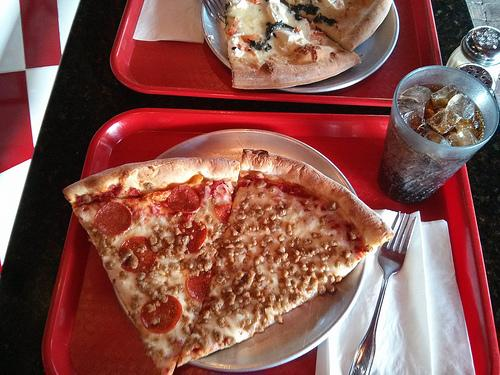Quantify and describe the types of drink-related elements included in the picture. There is one soft drink with ice cubes in a glass; the ice cubes have their own bounding box in the image. Count the number of forks mentioned in the image. There are 3 mentions of forks in the image. Determine the kind of setting that has been prepared for dining. A place setting for two people has been prepared in the image. Identify the number and types of pizza slices present in the image. There are four big slices of pizza, with three kinds: one pepperoni slice, one slice with sausage crumbles, and two slices of spinach pizza. What objects are present on a typical place setting for this meal? A place setting for this meal includes a slice of pizza on a plate, a fork on a napkin, a soft drink with ice, and cheese and pepper shakers. What kind of linoleum is mentioned in the image? There is checkered white and red linoleum mentioned in the image details. Describe the objects present in the image with the largest dimensions. Food on a red tray includes pizza slices, a soft drink with ice, a white napkin and a fork, and cheese and pepper shakers. Analyze the image sentiment and describe it briefly. The image sentiment seems to be a casual and enjoyable meal with various tasty pizza options and refreshing soft drinks. Comment on the quality of the pizza crust. The pizza crust is mentioned to be brown, likely indicating a well-cooked quality. How many trays are visible, and what is their color? Two red trays are visible in the image. 